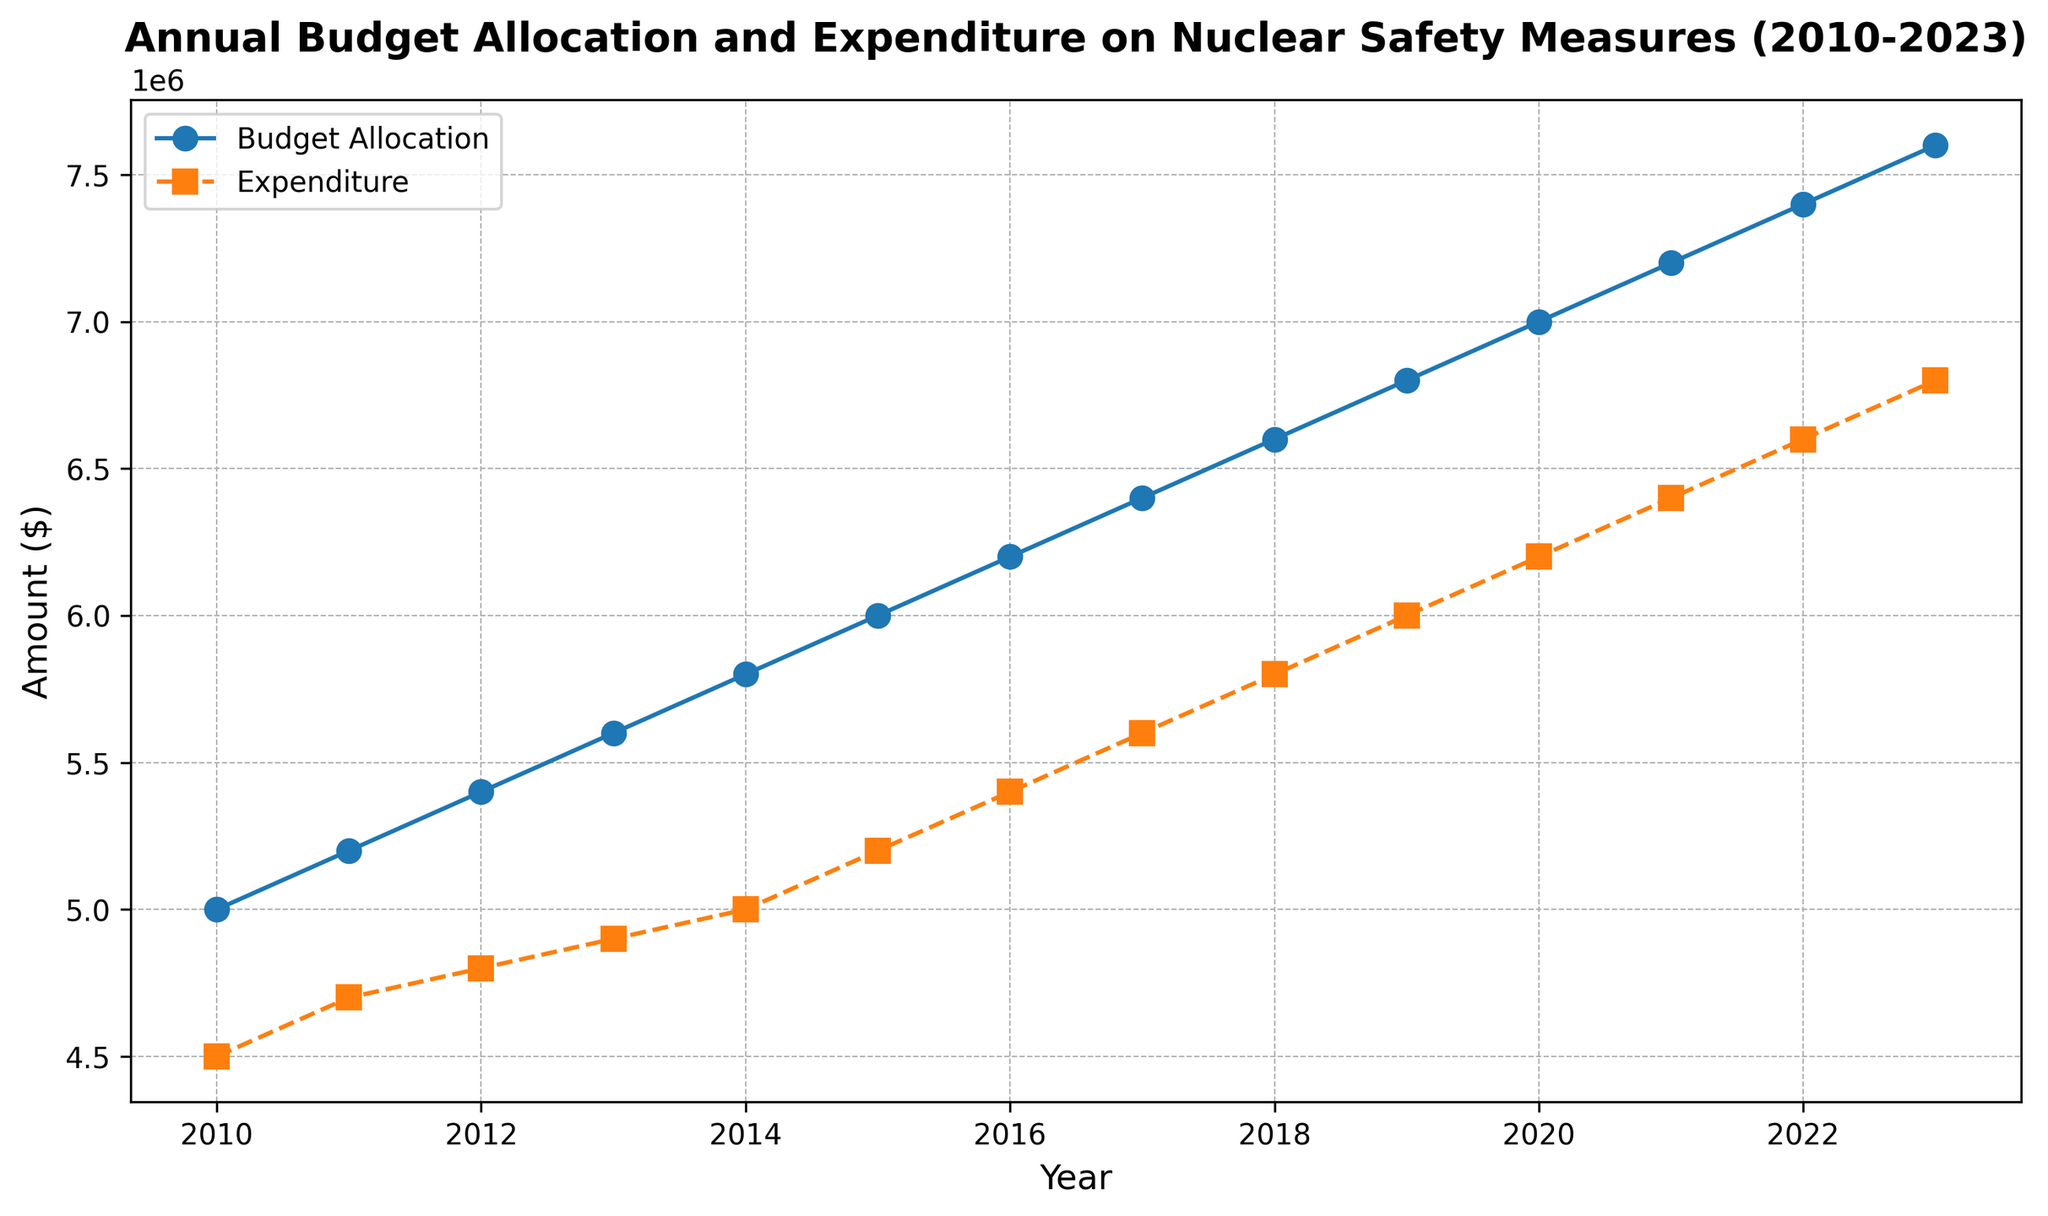What is the overall trend in the Budget Allocation from 2010 to 2023? The Budget Allocation shows a steady increasing trend over the years from 2010 to 2023, starting at $5,000,000 in 2010 and rising to $7,600,000 in 2023.
Answer: Increasing trend How much did the Expenditure increase from 2010 to 2023? To find the increase in Expenditure from 2010 to 2023, subtract the Expenditure in 2010 from the Expenditure in 2023: $6,800,000 (2023) - $4,500,000 (2010) = $2,300,000.
Answer: $2,300,000 In which year is the gap between Budget Allocation and Expenditure the largest? The largest gap between Budget Allocation and Expenditure can be observed by identifying the year where the distance between the two curves is greatest. This occurs in 2023, with a Budget Allocation of $7,600,000 and Expenditure of $6,800,000, making the gap $800,000.
Answer: 2023 What is the average annual increase in Budget Allocation from 2010 to 2023? First, find the total increase over the years: $7,600,000 (2023) - $5,000,000 (2010) = $2,600,000. Then, divide by the number of years: $2,600,000 / 13 years = $200,000 per year.
Answer: $200,000 per year By how much did the Expenditure increase on average each year from 2010 to 2023? First, find the total increase: $6,800,000 (2023) - $4,500,000 (2010) = $2,300,000. Next, divide by the number of years: $2,300,000 / 13 years ≈ $176,923.08 per year.
Answer: Approximately $176,923 per year In which years are Budget Allocation and Expenditure equal in terms of growth? The Budget Allocation and Expenditure growth are parallel, each showing a steady increase. The equality in growth refers to the years where their increments have similar patterns. Visually, there are no specific intersections, but all years show parallel growth.
Answer: Parallel growth throughout the period How does the Budget Allocation in 2015 compare to the Expenditure in the same year visually? In 2015, the Budget Allocation curve is higher than the Expenditure curve. Specifically, the Budget Allocation is $6,000,000 while Expenditure is $5,200,000.
Answer: Budget Allocation is higher Which line, Budget Allocation or Expenditure, demonstrates more variability over the years? Visually, both lines show steady increases without sharp fluctuations. However, Expenditure has a slightly smoother increase, indicating less variability compared to Budget Allocation.
Answer: Budget Allocation is more variable Calculate the difference in Expenditure between 2012 and 2017. To calculate the difference, subtract the Expenditure value in 2012 from the Expenditure value in 2017: $5,600,000 (2017) - $4,800,000 (2012) = $800,000.
Answer: $800,000 Is there any year where the Expenditure did not increase compared to the previous year? By observing the plotted data points, every year's Expenditure increases consistently compared to the previous year, without any stagnation or decrease.
Answer: No 